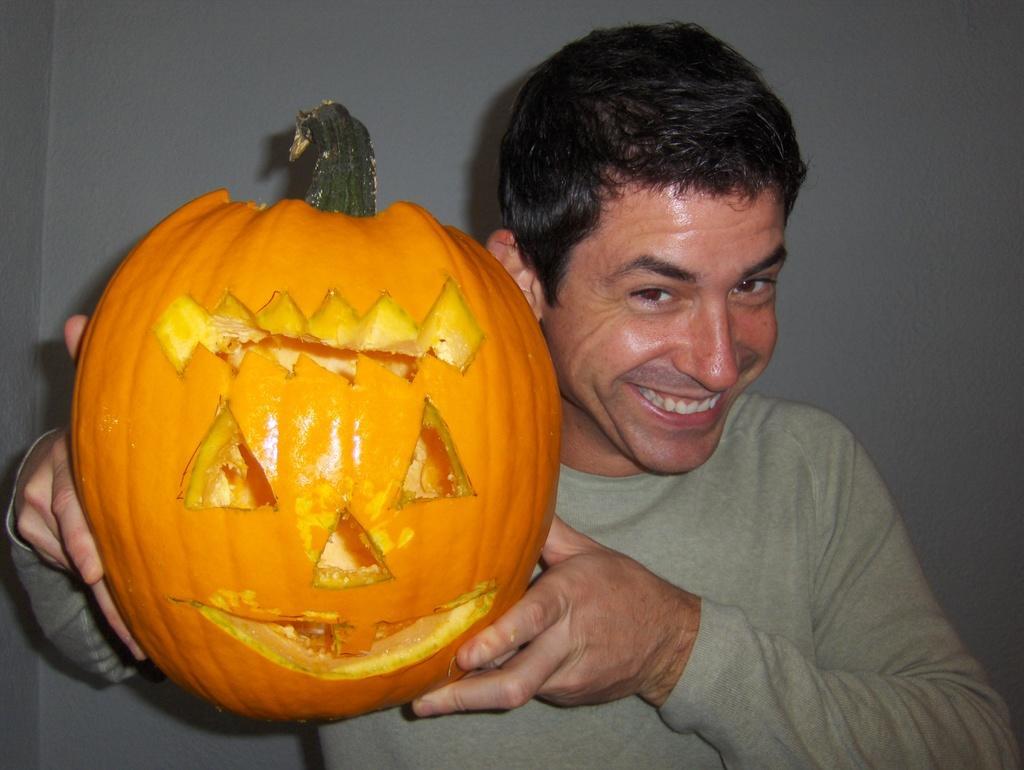Describe this image in one or two sentences. In the image there is a man holding a pumpkin carved in the shape of a Halloween pumpkin. 